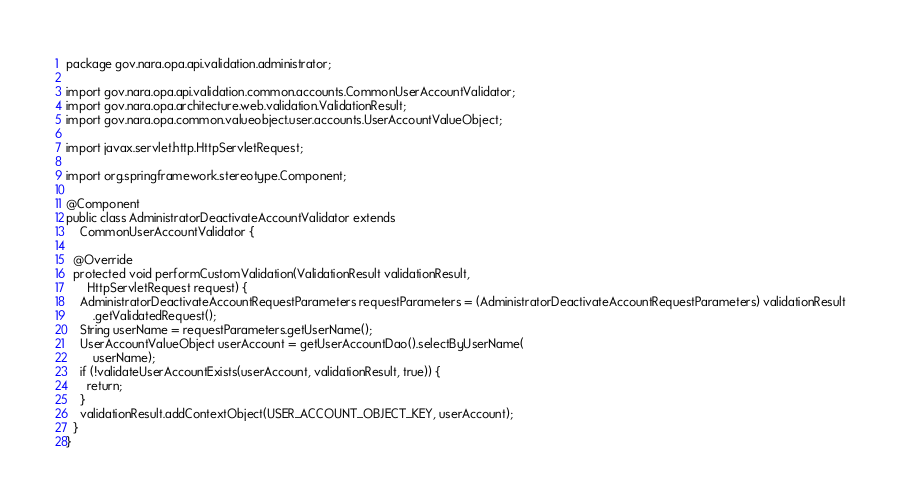<code> <loc_0><loc_0><loc_500><loc_500><_Java_>package gov.nara.opa.api.validation.administrator;

import gov.nara.opa.api.validation.common.accounts.CommonUserAccountValidator;
import gov.nara.opa.architecture.web.validation.ValidationResult;
import gov.nara.opa.common.valueobject.user.accounts.UserAccountValueObject;

import javax.servlet.http.HttpServletRequest;

import org.springframework.stereotype.Component;

@Component
public class AdministratorDeactivateAccountValidator extends
    CommonUserAccountValidator {

  @Override
  protected void performCustomValidation(ValidationResult validationResult,
      HttpServletRequest request) {
    AdministratorDeactivateAccountRequestParameters requestParameters = (AdministratorDeactivateAccountRequestParameters) validationResult
        .getValidatedRequest();
    String userName = requestParameters.getUserName();
    UserAccountValueObject userAccount = getUserAccountDao().selectByUserName(
        userName);
    if (!validateUserAccountExists(userAccount, validationResult, true)) {
      return;
    }
    validationResult.addContextObject(USER_ACCOUNT_OBJECT_KEY, userAccount);
  }
}
</code> 